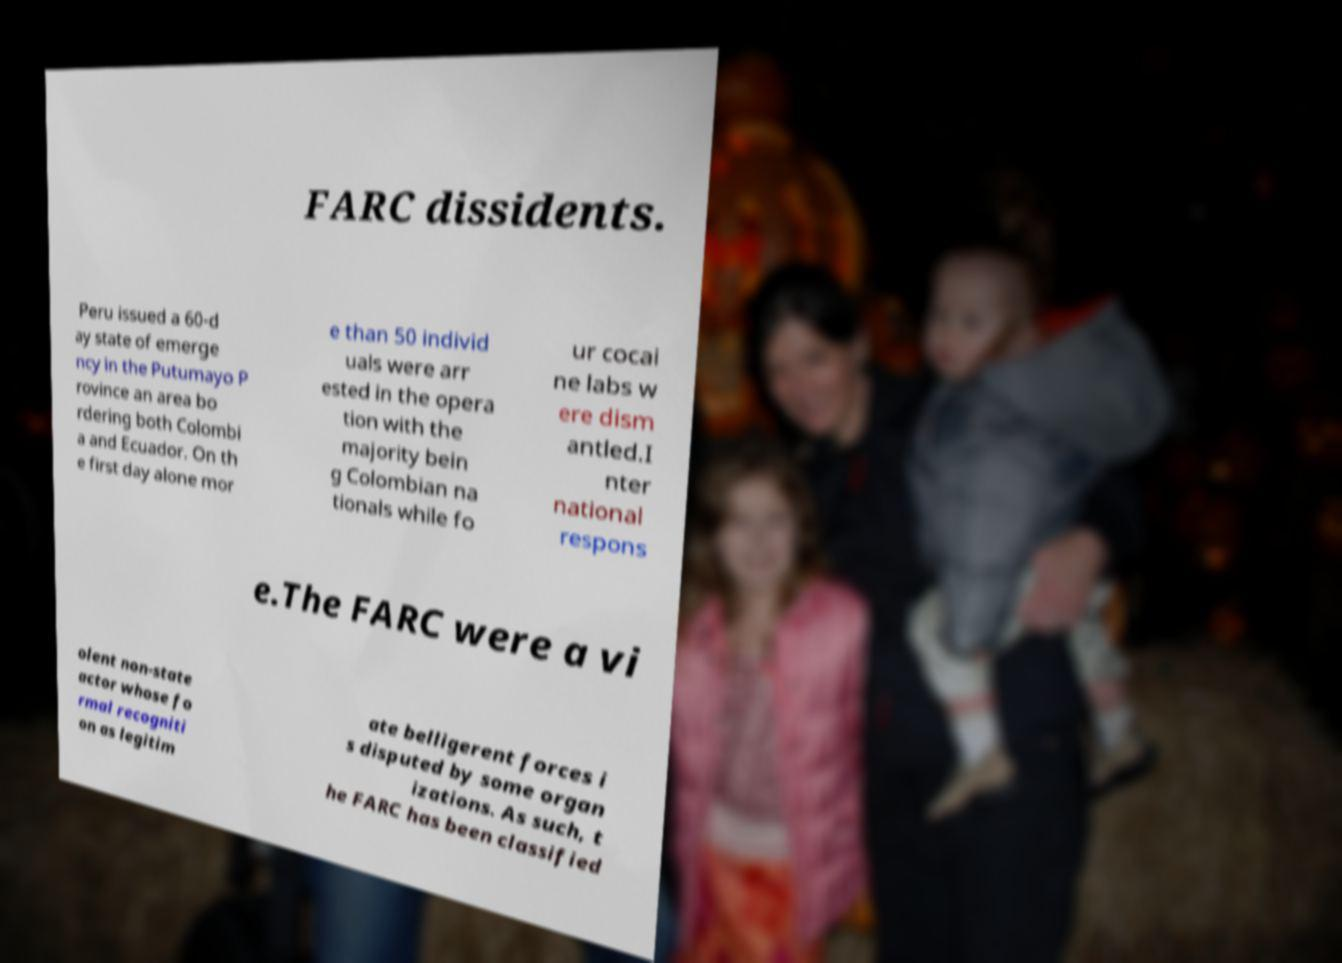For documentation purposes, I need the text within this image transcribed. Could you provide that? FARC dissidents. Peru issued a 60-d ay state of emerge ncy in the Putumayo P rovince an area bo rdering both Colombi a and Ecuador. On th e first day alone mor e than 50 individ uals were arr ested in the opera tion with the majority bein g Colombian na tionals while fo ur cocai ne labs w ere dism antled.I nter national respons e.The FARC were a vi olent non-state actor whose fo rmal recogniti on as legitim ate belligerent forces i s disputed by some organ izations. As such, t he FARC has been classified 